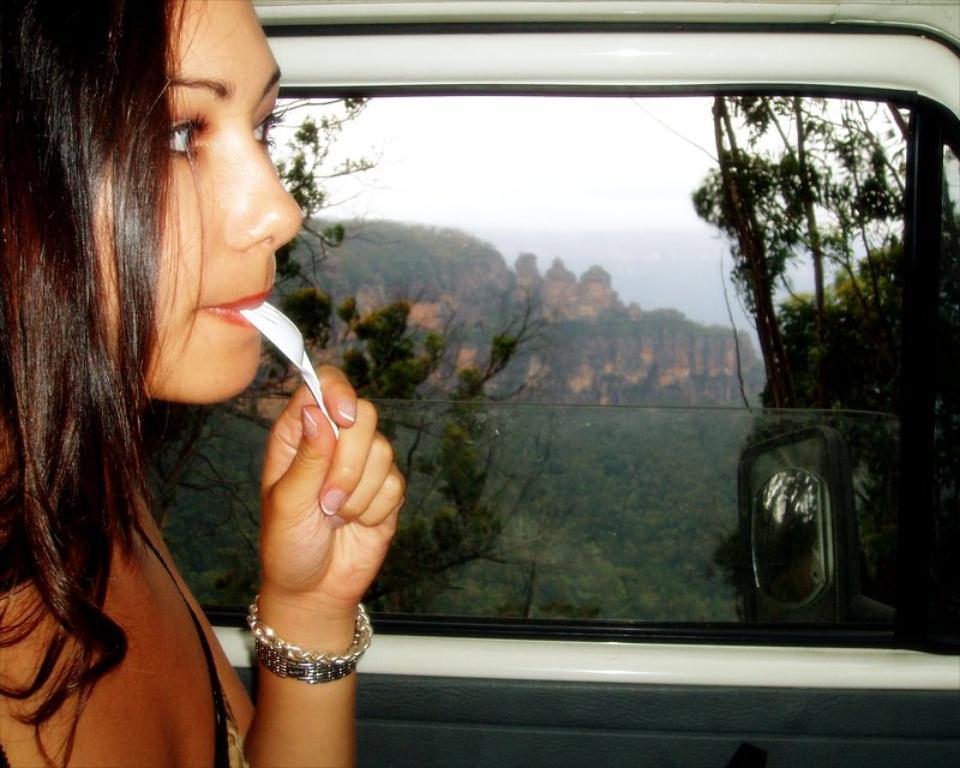Can you describe this image briefly? In the foreground of this image, on the left, there is a woman holding a spoon in her mouth. Behind her, there is a glass window and a mirror of a vehicle. In the background, there are trees, a cliff and the sky. 